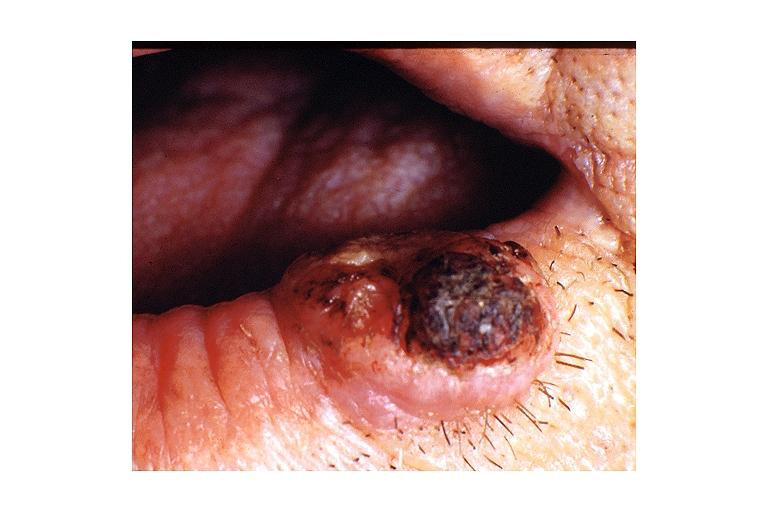s oral present?
Answer the question using a single word or phrase. Yes 